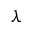Convert formula to latex. <formula><loc_0><loc_0><loc_500><loc_500>\lambda</formula> 